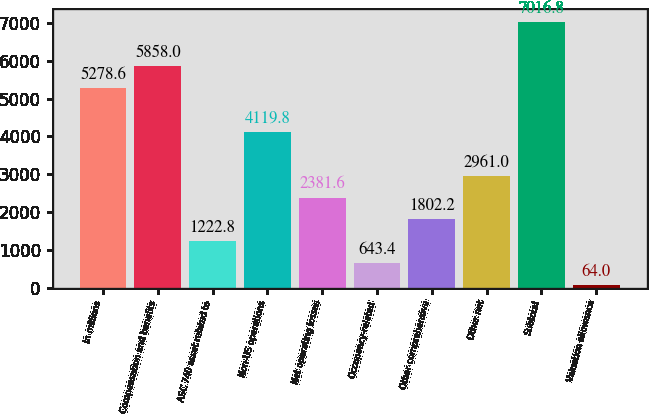<chart> <loc_0><loc_0><loc_500><loc_500><bar_chart><fcel>in millions<fcel>Compensation and benefits<fcel>ASC 740 asset related to<fcel>Non-US operations<fcel>Net operating losses<fcel>Occupancy-related<fcel>Other comprehensive<fcel>Other net<fcel>Subtotal<fcel>Valuation allowance<nl><fcel>5278.6<fcel>5858<fcel>1222.8<fcel>4119.8<fcel>2381.6<fcel>643.4<fcel>1802.2<fcel>2961<fcel>7016.8<fcel>64<nl></chart> 